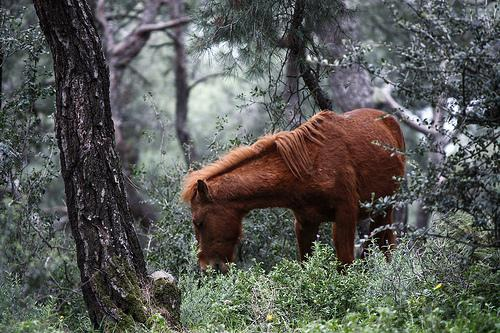Question: when was the photo taken?
Choices:
A. New Years Eve.
B. 12:09.
C. During a snowstorm.
D. Daytime.
Answer with the letter. Answer: D Question: what is the horse doing?
Choices:
A. Eating.
B. Running.
C. Kicking.
D. Laying on the ground.
Answer with the letter. Answer: A Question: where was the photo taken?
Choices:
A. On the beach.
B. Under the water.
C. In the woods.
D. Next to the building.
Answer with the letter. Answer: C 